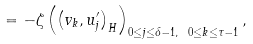<formula> <loc_0><loc_0><loc_500><loc_500>= - \zeta \left ( \left ( v _ { k } , u _ { j } ^ { \prime } \right ) _ { H } \right ) _ { 0 \leq j \leq \delta - 1 , \ 0 \leq k \leq \tau - 1 } ,</formula> 